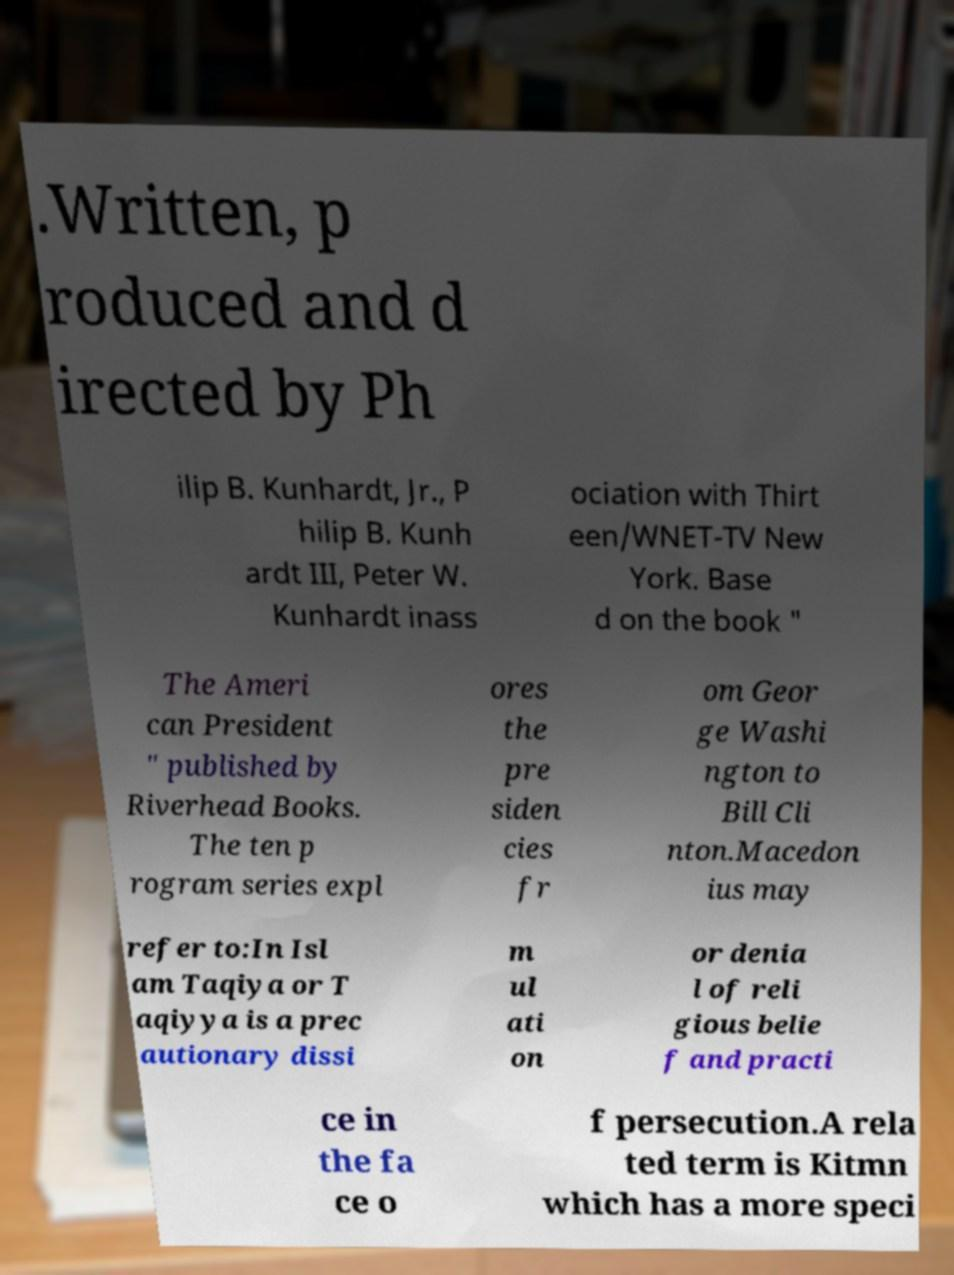I need the written content from this picture converted into text. Can you do that? .Written, p roduced and d irected by Ph ilip B. Kunhardt, Jr., P hilip B. Kunh ardt III, Peter W. Kunhardt inass ociation with Thirt een/WNET-TV New York. Base d on the book " The Ameri can President " published by Riverhead Books. The ten p rogram series expl ores the pre siden cies fr om Geor ge Washi ngton to Bill Cli nton.Macedon ius may refer to:In Isl am Taqiya or T aqiyya is a prec autionary dissi m ul ati on or denia l of reli gious belie f and practi ce in the fa ce o f persecution.A rela ted term is Kitmn which has a more speci 